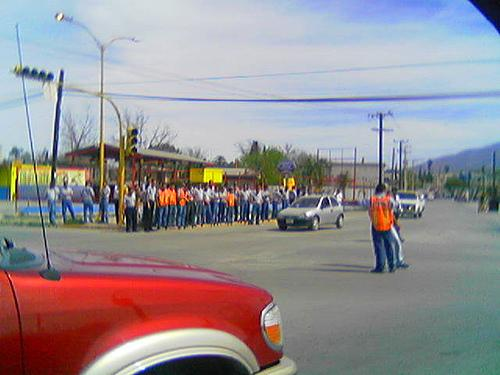What are these people doing here?

Choices:
A) hired
B) help riders
C) awaiting ride
D) invited yesterday awaiting ride 